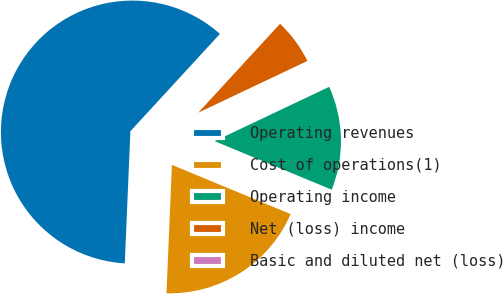Convert chart to OTSL. <chart><loc_0><loc_0><loc_500><loc_500><pie_chart><fcel>Operating revenues<fcel>Cost of operations(1)<fcel>Operating income<fcel>Net (loss) income<fcel>Basic and diluted net (loss)<nl><fcel>61.17%<fcel>19.42%<fcel>13.3%<fcel>6.12%<fcel>0.0%<nl></chart> 